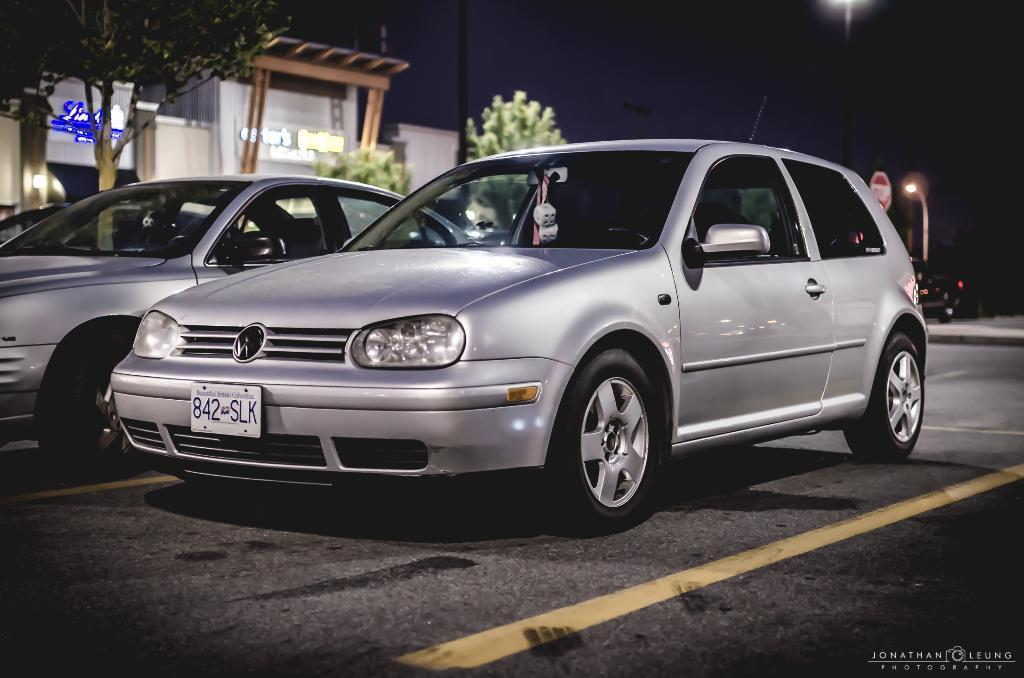What is happening on the road in the image? Vehicles are on the road in the image. How would you describe the background of the image? The background is blurred, and there are buildings, a tree, a signboard, and a light pole visible. How many women are seen cleaning the vehicles in the image? There are no women or any indication of cleaning in the image. 